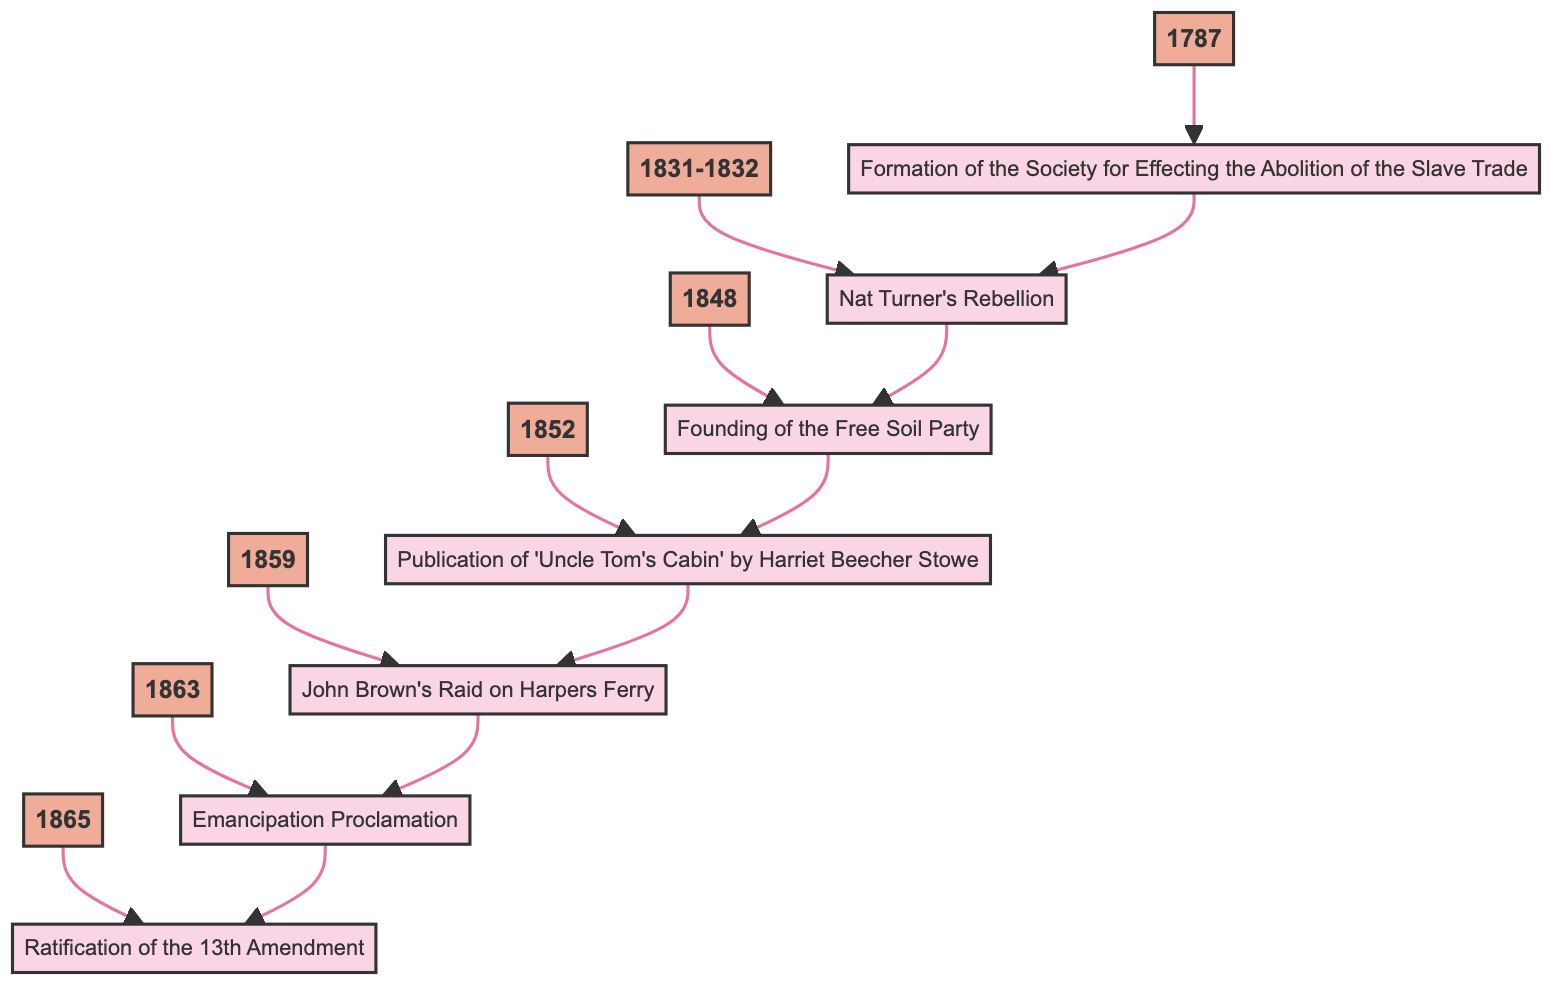What year was the Formation of the Society for Effecting the Abolition of the Slave Trade? The diagram indicates that the event "Formation of the Society for Effecting the Abolition of the Slave Trade" is connected to the year 1787.
Answer: 1787 What event occurred immediately before John Brown's Raid on Harpers Ferry? Following the flow in the diagram, the event directly connected before John Brown's Raid on Harpers Ferry is "Publication of 'Uncle Tom's Cabin' by Harriet Beecher Stowe."
Answer: Publication of 'Uncle Tom's Cabin' by Harriet Beecher Stowe How many key events are illustrated in this flow chart? The diagram lists a total of seven distinct events related to the Abolition Movement, as indicated by seven event nodes.
Answer: 7 What is the relationship between the Emancipation Proclamation and the Ratification of the 13th Amendment? The diagram shows a direct connection where the Emancipation Proclamation (1863) leads to the Ratification of the 13th Amendment (1865), indicating a chronological flow.
Answer: Emancipation Proclamation leads to Ratification of the 13th Amendment What year corresponds with Nat Turner's Rebellion? The flow chart connects Nat Turner's Rebellion with the years 1831-1832, as indicated in the year node.
Answer: 1831-1832 What was the main objective of the Free Soil Party, as represented in the diagram? The diagram indicates that the Free Soil Party was established primarily to oppose the expansion of slavery into western territories, which is summarized in its description.
Answer: Oppose the expansion of slavery Which event is associated with the year 1863? The diagram directly connects the year 1863 with the event "Emancipation Proclamation," highlighting its significance in that year.
Answer: Emancipation Proclamation What two events are linked by the years 1848 and 1852? Following the diagram flow, the event in 1848 is the "Founding of the Free Soil Party," and the subsequent event in 1852 is the "Publication of 'Uncle Tom's Cabin' by Harriet Beecher Stowe," showing a temporal sequence.
Answer: Founding of the Free Soil Party and Publication of 'Uncle Tom's Cabin' by Harriet Beecher Stowe 